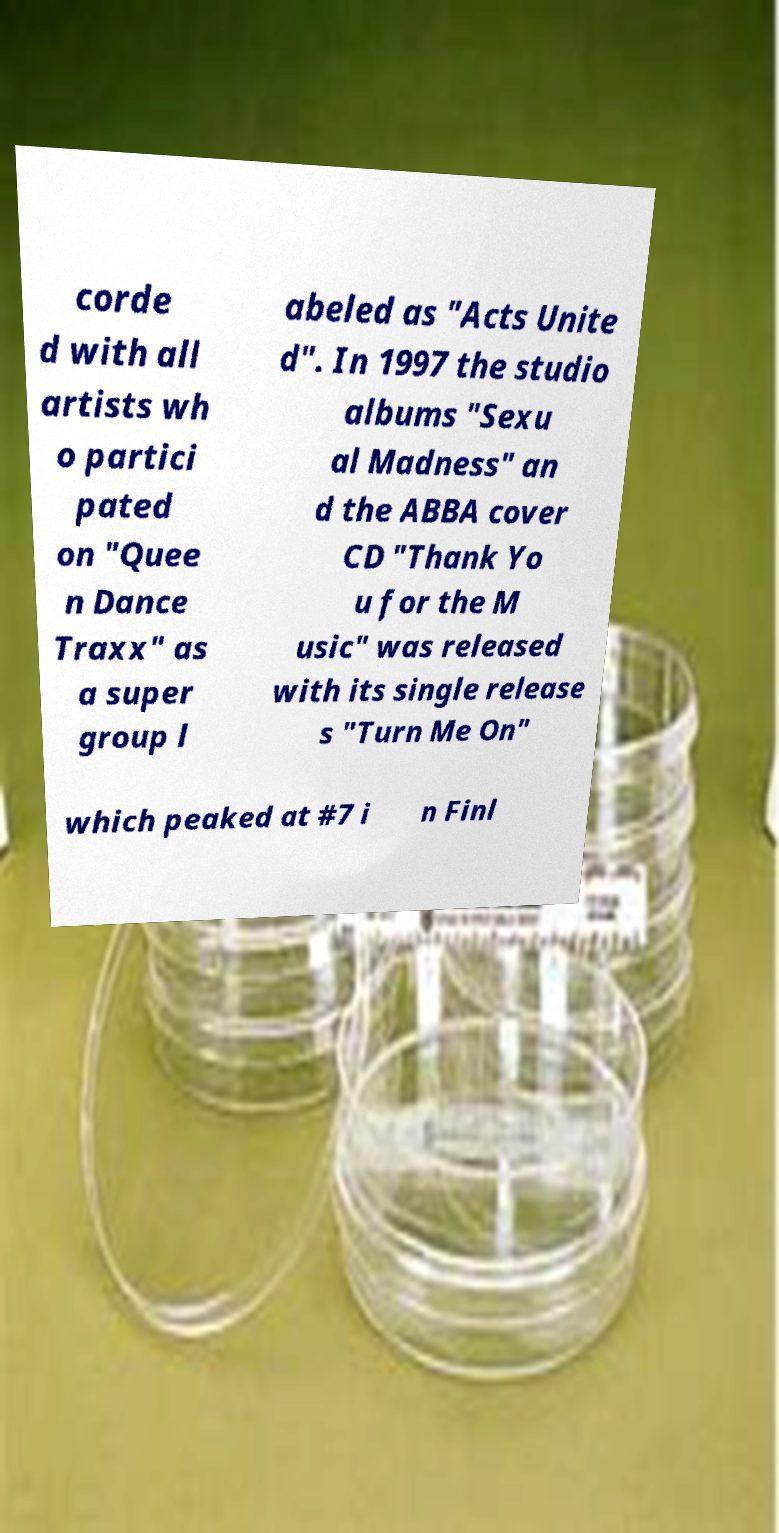Could you extract and type out the text from this image? corde d with all artists wh o partici pated on "Quee n Dance Traxx" as a super group l abeled as "Acts Unite d". In 1997 the studio albums "Sexu al Madness" an d the ABBA cover CD "Thank Yo u for the M usic" was released with its single release s "Turn Me On" which peaked at #7 i n Finl 